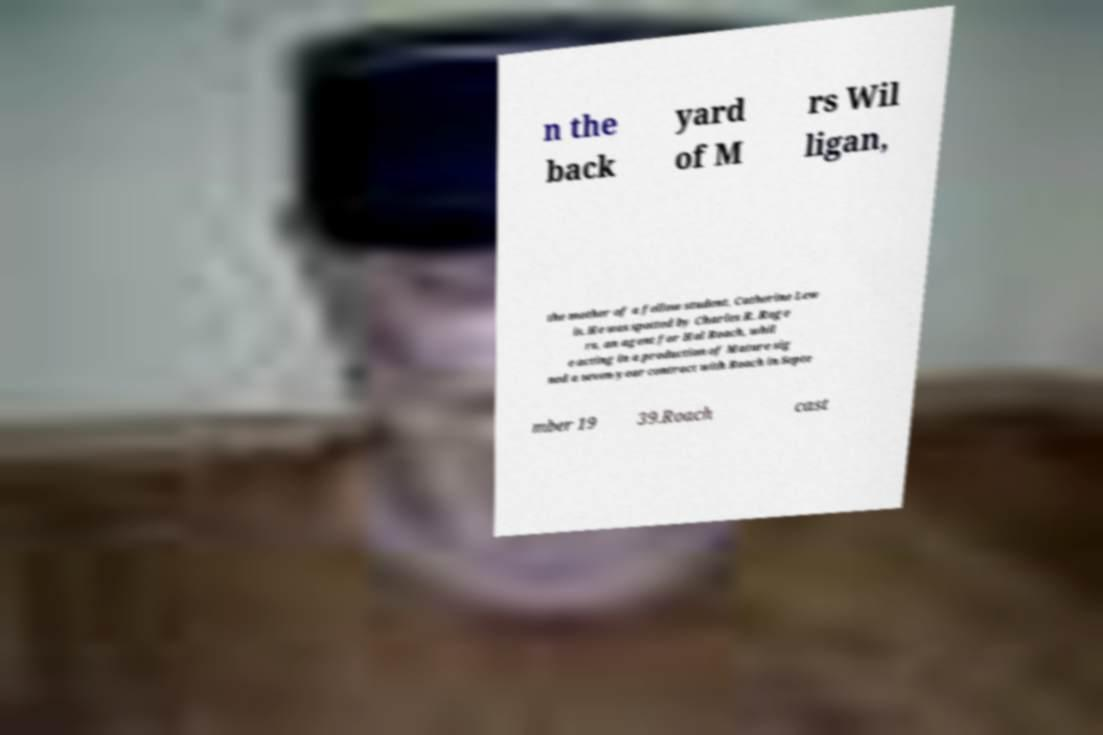Please read and relay the text visible in this image. What does it say? n the back yard of M rs Wil ligan, the mother of a fellow student, Catherine Lew is. He was spotted by Charles R. Roge rs, an agent for Hal Roach, whil e acting in a production of Mature sig ned a seven-year contract with Roach in Septe mber 19 39.Roach cast 